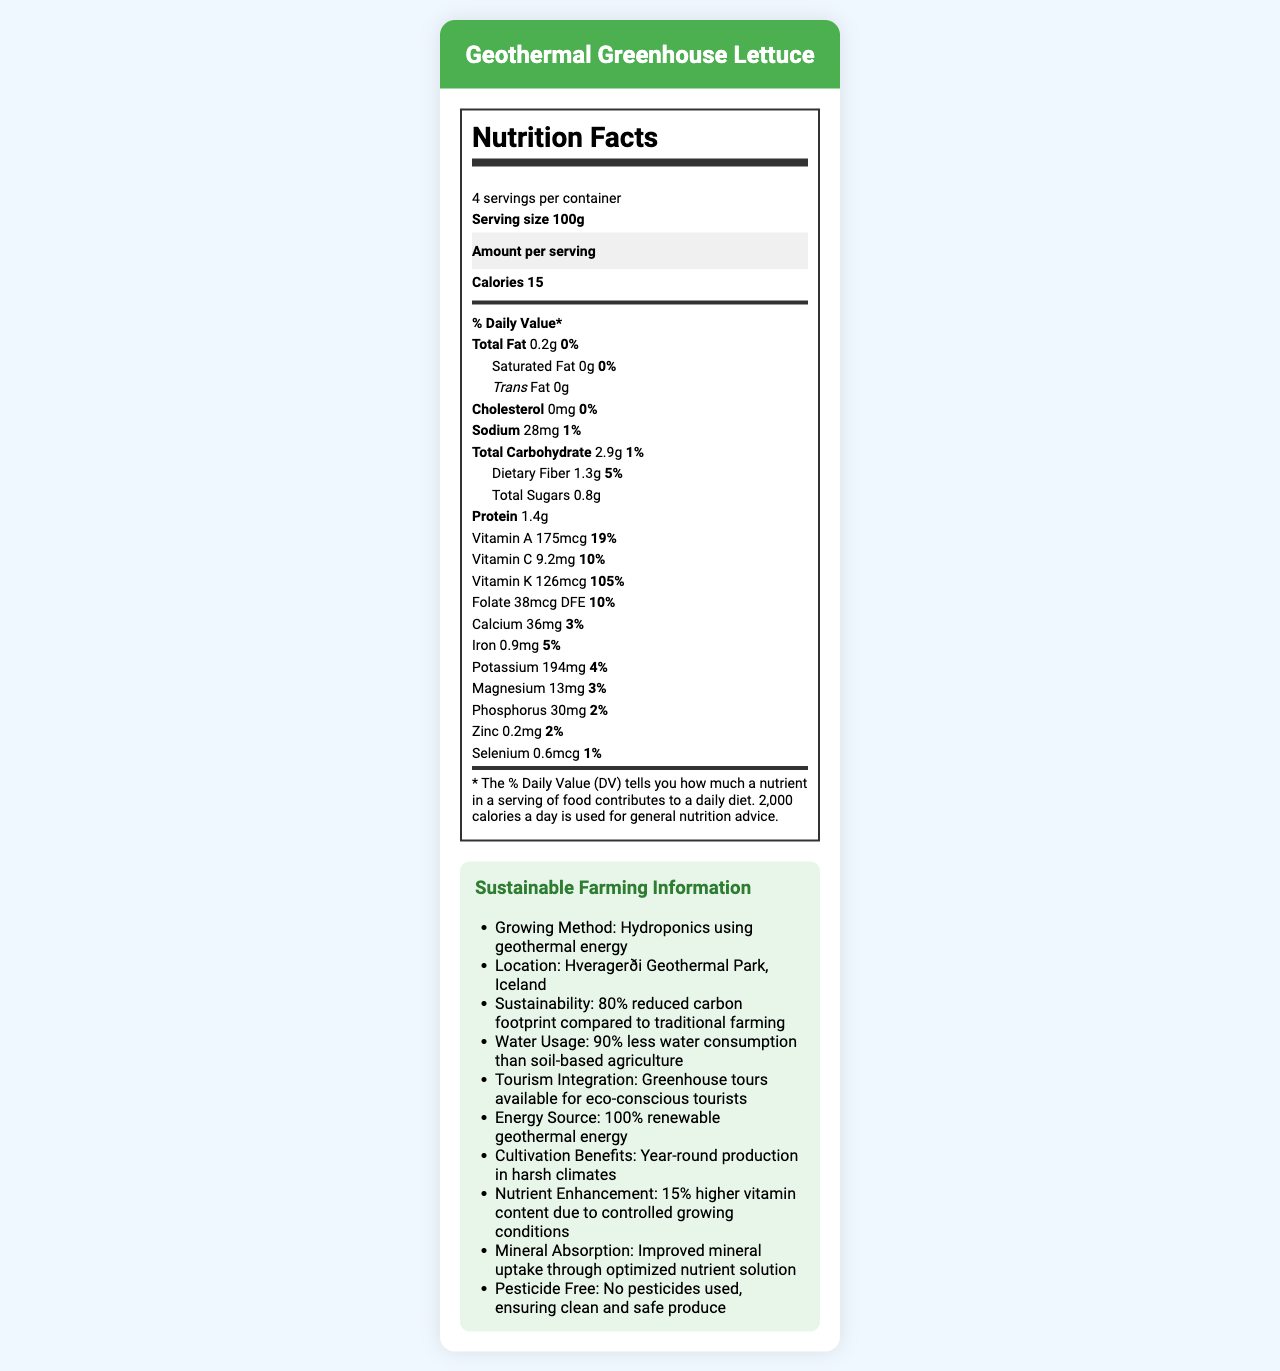what is the serving size of the Geothermal Greenhouse Lettuce? The serving size is explicitly mentioned as "100g" in the Nutrition Facts section.
Answer: 100g how many servings per container are there? The document states "4 servings per container" in the Nutrition Facts section.
Answer: 4 how many calories are in one serving? The calories per serving are listed as "15" in the Nutrition Facts section.
Answer: 15 what is the percentage of daily value for Vitamin A in one serving? The Vitamin A content of one serving has a daily value percentage of 19%, as indicated in the Nutrition Facts.
Answer: 19% does this product contain any trans fat? The document states "Trans Fat 0g", which means there is no trans fat in the product.
Answer: No how much dietary fiber is in one serving of lettuce? The Nutrition Facts section lists 1.3g of dietary fiber per serving.
Answer: 1.3g what is the main energy source used in the production of this lettuce? A. Solar B. Geothermal C. Wind D. Hydro The additional information section specifies "Energy Source: 100% renewable geothermal energy".
Answer: B. Geothermal how much sodium is there in a serving of Geothermal Greenhouse Lettuce? A. 15mg B. 28mg C. 50mg D. 36mg The Nutrition Facts label lists "Sodium 28mg" per serving.
Answer: B. 28mg is this lettuce grown using pesticides? The document clearly states, "No pesticides used, ensuring clean and safe produce."
Answer: No what is the sustainability factor of this hydroponic method? The document mentions the sustainability factor as "80% reduced carbon footprint compared to traditional farming."
Answer: 80% reduced carbon footprint compared to traditional farming summarize the entire document. The document describes a lettuce product grown hydroponically using geothermal energy, emphasizing its nutritional value, sustainable farming practices, and its role in eco-tourism.
Answer: The Geothermal Greenhouse Lettuce is a hydroponic lettuce product grown using geothermal energy at Hveragerði Geothermal Park in Iceland. It boasts a 100g serving size, with one serving containing 15 calories. It has significant vitamin and mineral content such as Vitamin A, C, K, folate, calcium, iron, potassium, magnesium, phosphorus, zinc, and selenium. The lettuce is grown sustainably with an 80% reduced carbon footprint compared to traditional farming, using 90% less water, and without pesticides. The greenhouse also integrates with tourism, offering tours to eco-conscious visitors. how does the mineral absorption of this lettuce compare to traditional methods? The document mentions that the hydroponic method offers "Improved mineral uptake through optimized nutrient solution."
Answer: Improved mineral uptake through optimized nutrient solution what is the water usage efficiency of the geothermal greenhouse method compared to soil-based agriculture? The additional information states that the lettuce is grown with 90% less water consumption than traditional soil-based methods.
Answer: 90% less water consumption than soil-based agriculture how does the vitamin content of this product compare to other types of lettuce? According to the document, this lettuce has a 15% higher vitamin content compared to other types due to the controlled growing conditions.
Answer: 15% higher vitamin content due to controlled growing conditions how much protein is in one serving of the lettuce? The amount of protein per serving is listed as 1.4g in the Nutrition Facts.
Answer: 1.4g what are the cultivation benefits mentioned in the document? The document states that one of the cultivation benefits is "Year-round production in harsh climates."
Answer: Year-round production in harsh climates how much selenium is in one serving of the lettuce? The Nutrition Facts section lists 0.6mcg of selenium per serving.
Answer: 0.6mcg how sustainable is the geothermal energy used in the greenhouse? The document mentions the use of 100% renewable geothermal energy but does not provide specific details on the sustainability metrics of the energy used.
Answer: Not enough information 